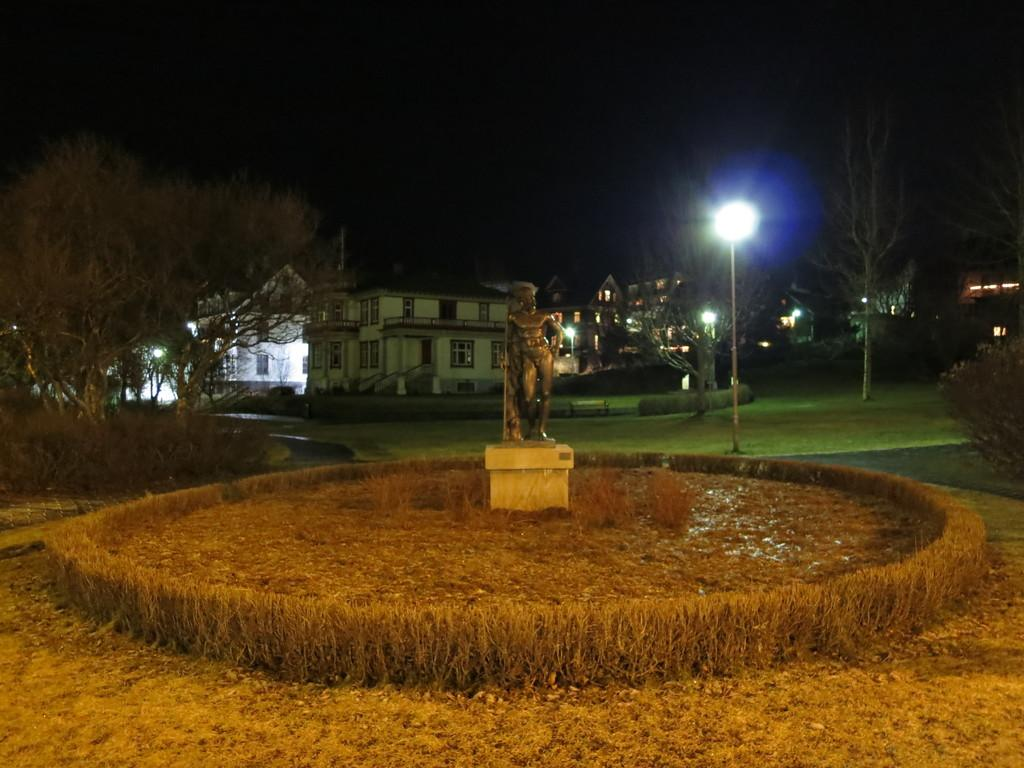What is the main subject in the image? There is a statue in the image. What type of environment surrounds the statue? There is grass around the statue. What can be seen on the left side of the image? There are trees on the left side of the image. What type of structures are present in the image? There are buildings in the image. What type of pathway is visible in the image? There is a walkway with poles in the image. How would you describe the sky in the image? The sky is dark in the image. Where is the book located in the image? There is no book present in the image. What type of office can be seen in the image? There is no office present in the image. 